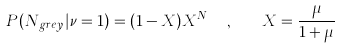Convert formula to latex. <formula><loc_0><loc_0><loc_500><loc_500>P ( N _ { g r e y } | \nu = 1 ) = ( 1 - X ) X ^ { N _ { g r e y } } , \quad X = \frac { \mu } { 1 + \mu }</formula> 